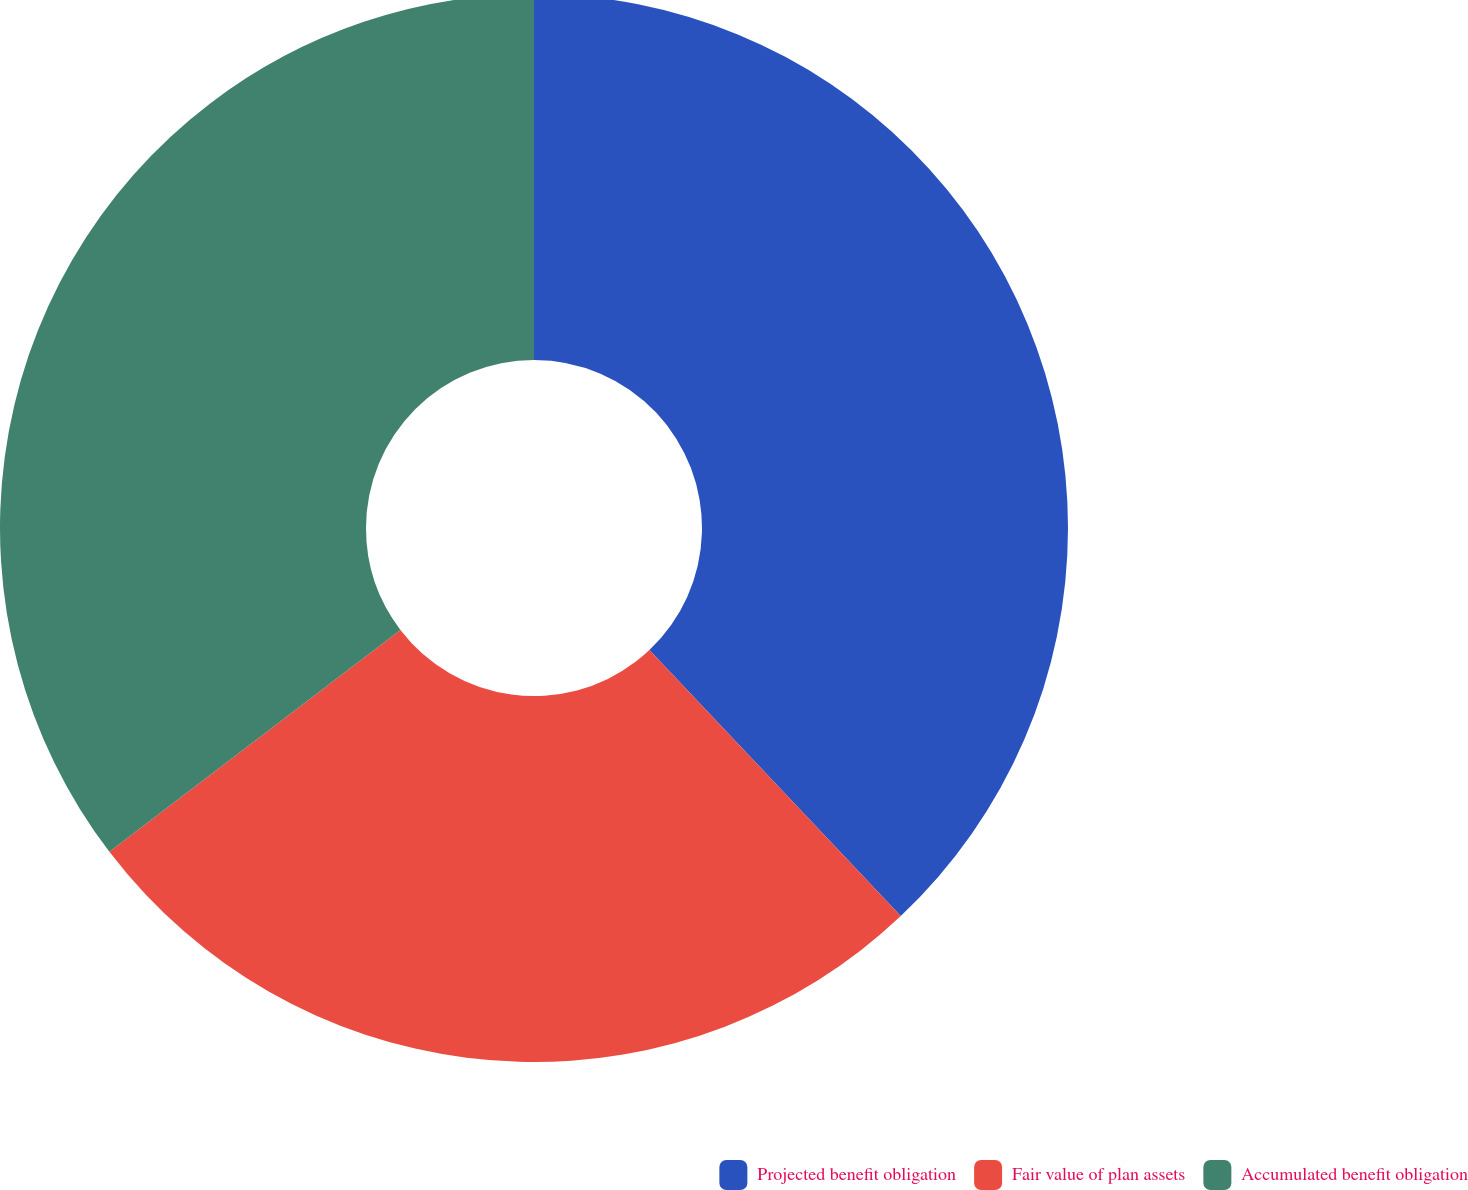<chart> <loc_0><loc_0><loc_500><loc_500><pie_chart><fcel>Projected benefit obligation<fcel>Fair value of plan assets<fcel>Accumulated benefit obligation<nl><fcel>37.95%<fcel>26.68%<fcel>35.37%<nl></chart> 